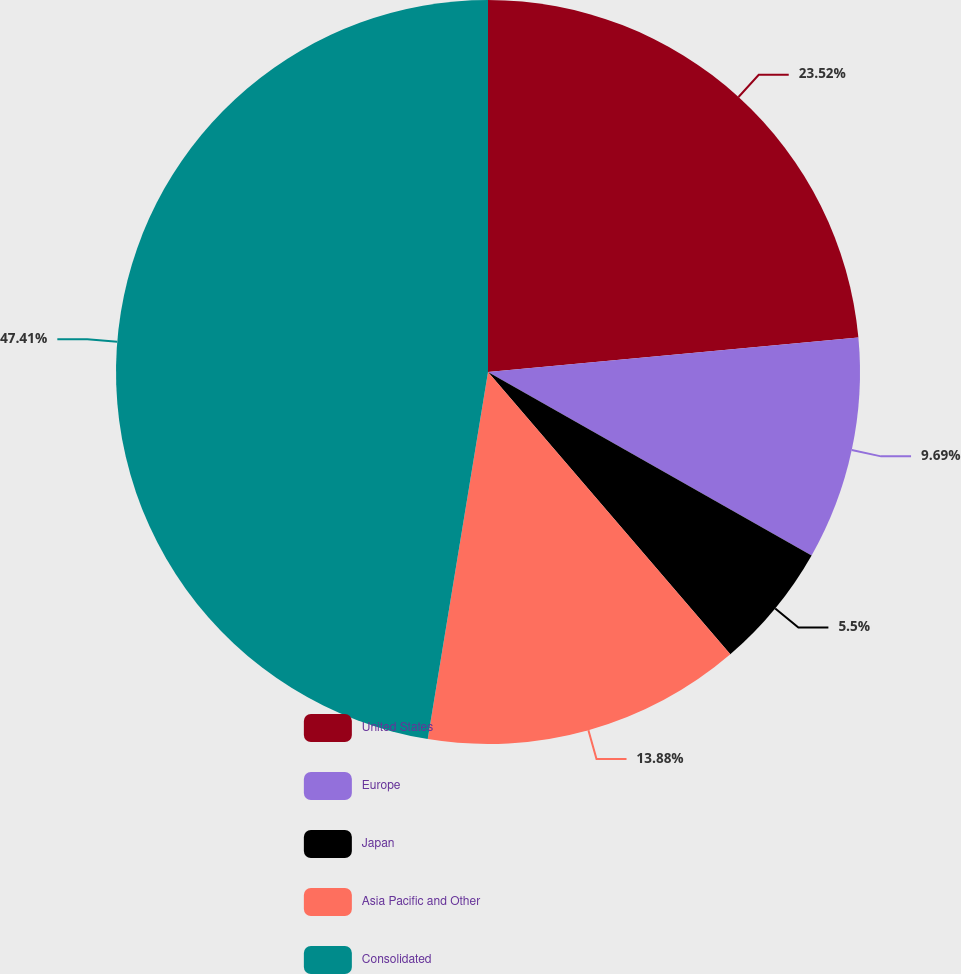<chart> <loc_0><loc_0><loc_500><loc_500><pie_chart><fcel>United States<fcel>Europe<fcel>Japan<fcel>Asia Pacific and Other<fcel>Consolidated<nl><fcel>23.52%<fcel>9.69%<fcel>5.5%<fcel>13.88%<fcel>47.41%<nl></chart> 